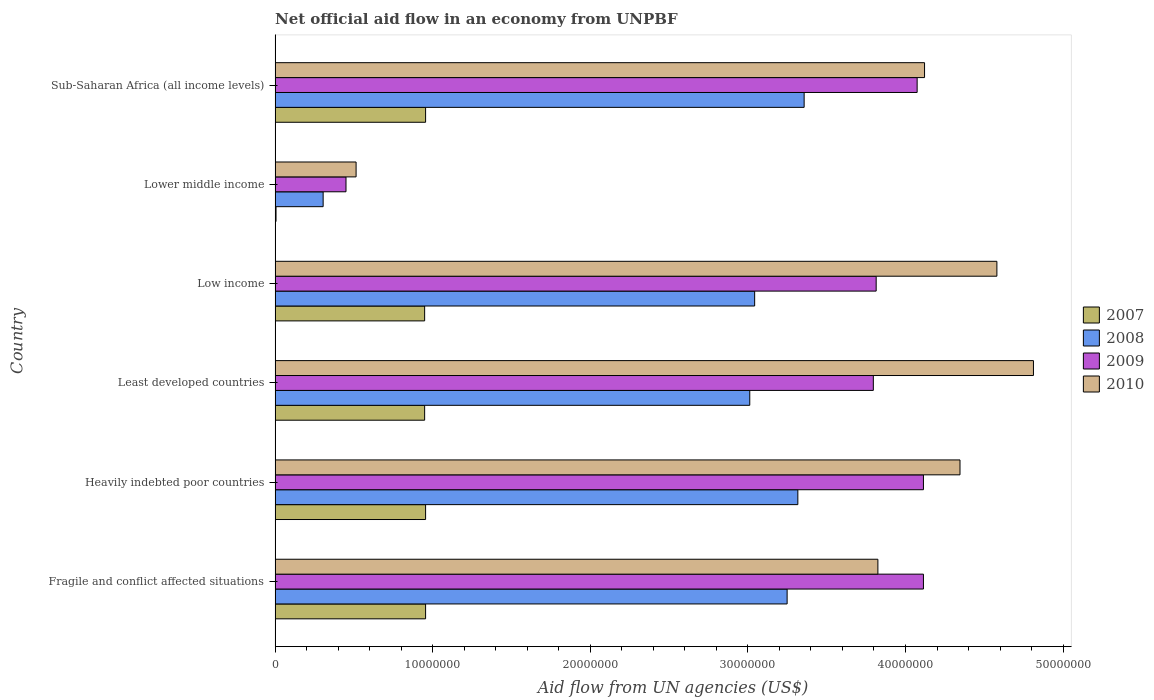How many different coloured bars are there?
Offer a terse response. 4. Are the number of bars on each tick of the Y-axis equal?
Provide a succinct answer. Yes. What is the label of the 2nd group of bars from the top?
Your answer should be compact. Lower middle income. In how many cases, is the number of bars for a given country not equal to the number of legend labels?
Provide a succinct answer. 0. What is the net official aid flow in 2010 in Sub-Saharan Africa (all income levels)?
Make the answer very short. 4.12e+07. Across all countries, what is the maximum net official aid flow in 2008?
Offer a terse response. 3.36e+07. Across all countries, what is the minimum net official aid flow in 2010?
Give a very brief answer. 5.14e+06. In which country was the net official aid flow in 2008 maximum?
Give a very brief answer. Sub-Saharan Africa (all income levels). In which country was the net official aid flow in 2008 minimum?
Give a very brief answer. Lower middle income. What is the total net official aid flow in 2008 in the graph?
Your answer should be very brief. 1.63e+08. What is the difference between the net official aid flow in 2007 in Low income and that in Sub-Saharan Africa (all income levels)?
Offer a terse response. -6.00e+04. What is the difference between the net official aid flow in 2009 in Sub-Saharan Africa (all income levels) and the net official aid flow in 2010 in Lower middle income?
Your answer should be very brief. 3.56e+07. What is the average net official aid flow in 2008 per country?
Provide a short and direct response. 2.71e+07. What is the difference between the net official aid flow in 2009 and net official aid flow in 2010 in Heavily indebted poor countries?
Keep it short and to the point. -2.32e+06. In how many countries, is the net official aid flow in 2010 greater than 48000000 US$?
Provide a short and direct response. 1. What is the ratio of the net official aid flow in 2010 in Lower middle income to that in Sub-Saharan Africa (all income levels)?
Your answer should be compact. 0.12. Is the net official aid flow in 2010 in Heavily indebted poor countries less than that in Least developed countries?
Provide a short and direct response. Yes. Is the difference between the net official aid flow in 2009 in Heavily indebted poor countries and Low income greater than the difference between the net official aid flow in 2010 in Heavily indebted poor countries and Low income?
Keep it short and to the point. Yes. What is the difference between the highest and the second highest net official aid flow in 2010?
Keep it short and to the point. 2.32e+06. What is the difference between the highest and the lowest net official aid flow in 2009?
Provide a succinct answer. 3.66e+07. In how many countries, is the net official aid flow in 2009 greater than the average net official aid flow in 2009 taken over all countries?
Your answer should be very brief. 5. What does the 2nd bar from the top in Fragile and conflict affected situations represents?
Give a very brief answer. 2009. How many bars are there?
Your answer should be very brief. 24. How many countries are there in the graph?
Your response must be concise. 6. Are the values on the major ticks of X-axis written in scientific E-notation?
Your answer should be compact. No. Does the graph contain any zero values?
Ensure brevity in your answer.  No. How many legend labels are there?
Your response must be concise. 4. What is the title of the graph?
Offer a terse response. Net official aid flow in an economy from UNPBF. Does "1980" appear as one of the legend labels in the graph?
Give a very brief answer. No. What is the label or title of the X-axis?
Your answer should be very brief. Aid flow from UN agencies (US$). What is the label or title of the Y-axis?
Give a very brief answer. Country. What is the Aid flow from UN agencies (US$) of 2007 in Fragile and conflict affected situations?
Give a very brief answer. 9.55e+06. What is the Aid flow from UN agencies (US$) in 2008 in Fragile and conflict affected situations?
Provide a succinct answer. 3.25e+07. What is the Aid flow from UN agencies (US$) of 2009 in Fragile and conflict affected situations?
Ensure brevity in your answer.  4.11e+07. What is the Aid flow from UN agencies (US$) of 2010 in Fragile and conflict affected situations?
Your answer should be compact. 3.82e+07. What is the Aid flow from UN agencies (US$) of 2007 in Heavily indebted poor countries?
Make the answer very short. 9.55e+06. What is the Aid flow from UN agencies (US$) in 2008 in Heavily indebted poor countries?
Your answer should be compact. 3.32e+07. What is the Aid flow from UN agencies (US$) of 2009 in Heavily indebted poor countries?
Your answer should be very brief. 4.11e+07. What is the Aid flow from UN agencies (US$) of 2010 in Heavily indebted poor countries?
Give a very brief answer. 4.35e+07. What is the Aid flow from UN agencies (US$) of 2007 in Least developed countries?
Your answer should be very brief. 9.49e+06. What is the Aid flow from UN agencies (US$) in 2008 in Least developed countries?
Your response must be concise. 3.01e+07. What is the Aid flow from UN agencies (US$) in 2009 in Least developed countries?
Keep it short and to the point. 3.80e+07. What is the Aid flow from UN agencies (US$) of 2010 in Least developed countries?
Offer a very short reply. 4.81e+07. What is the Aid flow from UN agencies (US$) in 2007 in Low income?
Make the answer very short. 9.49e+06. What is the Aid flow from UN agencies (US$) of 2008 in Low income?
Your response must be concise. 3.04e+07. What is the Aid flow from UN agencies (US$) in 2009 in Low income?
Your answer should be compact. 3.81e+07. What is the Aid flow from UN agencies (US$) in 2010 in Low income?
Provide a succinct answer. 4.58e+07. What is the Aid flow from UN agencies (US$) in 2007 in Lower middle income?
Provide a succinct answer. 6.00e+04. What is the Aid flow from UN agencies (US$) in 2008 in Lower middle income?
Keep it short and to the point. 3.05e+06. What is the Aid flow from UN agencies (US$) of 2009 in Lower middle income?
Provide a succinct answer. 4.50e+06. What is the Aid flow from UN agencies (US$) in 2010 in Lower middle income?
Give a very brief answer. 5.14e+06. What is the Aid flow from UN agencies (US$) in 2007 in Sub-Saharan Africa (all income levels)?
Provide a short and direct response. 9.55e+06. What is the Aid flow from UN agencies (US$) of 2008 in Sub-Saharan Africa (all income levels)?
Provide a succinct answer. 3.36e+07. What is the Aid flow from UN agencies (US$) in 2009 in Sub-Saharan Africa (all income levels)?
Offer a terse response. 4.07e+07. What is the Aid flow from UN agencies (US$) in 2010 in Sub-Saharan Africa (all income levels)?
Give a very brief answer. 4.12e+07. Across all countries, what is the maximum Aid flow from UN agencies (US$) in 2007?
Keep it short and to the point. 9.55e+06. Across all countries, what is the maximum Aid flow from UN agencies (US$) in 2008?
Provide a short and direct response. 3.36e+07. Across all countries, what is the maximum Aid flow from UN agencies (US$) of 2009?
Your answer should be compact. 4.11e+07. Across all countries, what is the maximum Aid flow from UN agencies (US$) in 2010?
Provide a short and direct response. 4.81e+07. Across all countries, what is the minimum Aid flow from UN agencies (US$) of 2007?
Make the answer very short. 6.00e+04. Across all countries, what is the minimum Aid flow from UN agencies (US$) of 2008?
Offer a terse response. 3.05e+06. Across all countries, what is the minimum Aid flow from UN agencies (US$) of 2009?
Offer a very short reply. 4.50e+06. Across all countries, what is the minimum Aid flow from UN agencies (US$) in 2010?
Ensure brevity in your answer.  5.14e+06. What is the total Aid flow from UN agencies (US$) in 2007 in the graph?
Your answer should be compact. 4.77e+07. What is the total Aid flow from UN agencies (US$) of 2008 in the graph?
Offer a terse response. 1.63e+08. What is the total Aid flow from UN agencies (US$) in 2009 in the graph?
Provide a succinct answer. 2.04e+08. What is the total Aid flow from UN agencies (US$) in 2010 in the graph?
Give a very brief answer. 2.22e+08. What is the difference between the Aid flow from UN agencies (US$) in 2007 in Fragile and conflict affected situations and that in Heavily indebted poor countries?
Offer a terse response. 0. What is the difference between the Aid flow from UN agencies (US$) in 2008 in Fragile and conflict affected situations and that in Heavily indebted poor countries?
Your answer should be very brief. -6.80e+05. What is the difference between the Aid flow from UN agencies (US$) in 2010 in Fragile and conflict affected situations and that in Heavily indebted poor countries?
Your response must be concise. -5.21e+06. What is the difference between the Aid flow from UN agencies (US$) in 2008 in Fragile and conflict affected situations and that in Least developed countries?
Provide a short and direct response. 2.37e+06. What is the difference between the Aid flow from UN agencies (US$) in 2009 in Fragile and conflict affected situations and that in Least developed countries?
Make the answer very short. 3.18e+06. What is the difference between the Aid flow from UN agencies (US$) in 2010 in Fragile and conflict affected situations and that in Least developed countries?
Keep it short and to the point. -9.87e+06. What is the difference between the Aid flow from UN agencies (US$) in 2008 in Fragile and conflict affected situations and that in Low income?
Give a very brief answer. 2.06e+06. What is the difference between the Aid flow from UN agencies (US$) in 2010 in Fragile and conflict affected situations and that in Low income?
Your response must be concise. -7.55e+06. What is the difference between the Aid flow from UN agencies (US$) of 2007 in Fragile and conflict affected situations and that in Lower middle income?
Your answer should be very brief. 9.49e+06. What is the difference between the Aid flow from UN agencies (US$) in 2008 in Fragile and conflict affected situations and that in Lower middle income?
Keep it short and to the point. 2.94e+07. What is the difference between the Aid flow from UN agencies (US$) in 2009 in Fragile and conflict affected situations and that in Lower middle income?
Your answer should be very brief. 3.66e+07. What is the difference between the Aid flow from UN agencies (US$) in 2010 in Fragile and conflict affected situations and that in Lower middle income?
Your answer should be very brief. 3.31e+07. What is the difference between the Aid flow from UN agencies (US$) in 2007 in Fragile and conflict affected situations and that in Sub-Saharan Africa (all income levels)?
Ensure brevity in your answer.  0. What is the difference between the Aid flow from UN agencies (US$) in 2008 in Fragile and conflict affected situations and that in Sub-Saharan Africa (all income levels)?
Give a very brief answer. -1.08e+06. What is the difference between the Aid flow from UN agencies (US$) of 2010 in Fragile and conflict affected situations and that in Sub-Saharan Africa (all income levels)?
Ensure brevity in your answer.  -2.96e+06. What is the difference between the Aid flow from UN agencies (US$) of 2007 in Heavily indebted poor countries and that in Least developed countries?
Give a very brief answer. 6.00e+04. What is the difference between the Aid flow from UN agencies (US$) in 2008 in Heavily indebted poor countries and that in Least developed countries?
Offer a terse response. 3.05e+06. What is the difference between the Aid flow from UN agencies (US$) of 2009 in Heavily indebted poor countries and that in Least developed countries?
Ensure brevity in your answer.  3.18e+06. What is the difference between the Aid flow from UN agencies (US$) of 2010 in Heavily indebted poor countries and that in Least developed countries?
Offer a terse response. -4.66e+06. What is the difference between the Aid flow from UN agencies (US$) in 2007 in Heavily indebted poor countries and that in Low income?
Provide a succinct answer. 6.00e+04. What is the difference between the Aid flow from UN agencies (US$) of 2008 in Heavily indebted poor countries and that in Low income?
Offer a terse response. 2.74e+06. What is the difference between the Aid flow from UN agencies (US$) in 2009 in Heavily indebted poor countries and that in Low income?
Your response must be concise. 3.00e+06. What is the difference between the Aid flow from UN agencies (US$) of 2010 in Heavily indebted poor countries and that in Low income?
Keep it short and to the point. -2.34e+06. What is the difference between the Aid flow from UN agencies (US$) of 2007 in Heavily indebted poor countries and that in Lower middle income?
Provide a succinct answer. 9.49e+06. What is the difference between the Aid flow from UN agencies (US$) in 2008 in Heavily indebted poor countries and that in Lower middle income?
Provide a short and direct response. 3.01e+07. What is the difference between the Aid flow from UN agencies (US$) of 2009 in Heavily indebted poor countries and that in Lower middle income?
Your response must be concise. 3.66e+07. What is the difference between the Aid flow from UN agencies (US$) of 2010 in Heavily indebted poor countries and that in Lower middle income?
Keep it short and to the point. 3.83e+07. What is the difference between the Aid flow from UN agencies (US$) of 2007 in Heavily indebted poor countries and that in Sub-Saharan Africa (all income levels)?
Make the answer very short. 0. What is the difference between the Aid flow from UN agencies (US$) of 2008 in Heavily indebted poor countries and that in Sub-Saharan Africa (all income levels)?
Keep it short and to the point. -4.00e+05. What is the difference between the Aid flow from UN agencies (US$) of 2009 in Heavily indebted poor countries and that in Sub-Saharan Africa (all income levels)?
Your answer should be very brief. 4.00e+05. What is the difference between the Aid flow from UN agencies (US$) of 2010 in Heavily indebted poor countries and that in Sub-Saharan Africa (all income levels)?
Provide a succinct answer. 2.25e+06. What is the difference between the Aid flow from UN agencies (US$) in 2008 in Least developed countries and that in Low income?
Your answer should be very brief. -3.10e+05. What is the difference between the Aid flow from UN agencies (US$) of 2009 in Least developed countries and that in Low income?
Provide a short and direct response. -1.80e+05. What is the difference between the Aid flow from UN agencies (US$) of 2010 in Least developed countries and that in Low income?
Your answer should be very brief. 2.32e+06. What is the difference between the Aid flow from UN agencies (US$) in 2007 in Least developed countries and that in Lower middle income?
Ensure brevity in your answer.  9.43e+06. What is the difference between the Aid flow from UN agencies (US$) in 2008 in Least developed countries and that in Lower middle income?
Your answer should be very brief. 2.71e+07. What is the difference between the Aid flow from UN agencies (US$) in 2009 in Least developed countries and that in Lower middle income?
Make the answer very short. 3.35e+07. What is the difference between the Aid flow from UN agencies (US$) of 2010 in Least developed countries and that in Lower middle income?
Your answer should be compact. 4.30e+07. What is the difference between the Aid flow from UN agencies (US$) in 2008 in Least developed countries and that in Sub-Saharan Africa (all income levels)?
Your answer should be very brief. -3.45e+06. What is the difference between the Aid flow from UN agencies (US$) in 2009 in Least developed countries and that in Sub-Saharan Africa (all income levels)?
Give a very brief answer. -2.78e+06. What is the difference between the Aid flow from UN agencies (US$) in 2010 in Least developed countries and that in Sub-Saharan Africa (all income levels)?
Ensure brevity in your answer.  6.91e+06. What is the difference between the Aid flow from UN agencies (US$) in 2007 in Low income and that in Lower middle income?
Your answer should be very brief. 9.43e+06. What is the difference between the Aid flow from UN agencies (US$) of 2008 in Low income and that in Lower middle income?
Ensure brevity in your answer.  2.74e+07. What is the difference between the Aid flow from UN agencies (US$) of 2009 in Low income and that in Lower middle income?
Keep it short and to the point. 3.36e+07. What is the difference between the Aid flow from UN agencies (US$) of 2010 in Low income and that in Lower middle income?
Make the answer very short. 4.07e+07. What is the difference between the Aid flow from UN agencies (US$) in 2008 in Low income and that in Sub-Saharan Africa (all income levels)?
Offer a very short reply. -3.14e+06. What is the difference between the Aid flow from UN agencies (US$) in 2009 in Low income and that in Sub-Saharan Africa (all income levels)?
Offer a terse response. -2.60e+06. What is the difference between the Aid flow from UN agencies (US$) of 2010 in Low income and that in Sub-Saharan Africa (all income levels)?
Ensure brevity in your answer.  4.59e+06. What is the difference between the Aid flow from UN agencies (US$) in 2007 in Lower middle income and that in Sub-Saharan Africa (all income levels)?
Keep it short and to the point. -9.49e+06. What is the difference between the Aid flow from UN agencies (US$) in 2008 in Lower middle income and that in Sub-Saharan Africa (all income levels)?
Offer a very short reply. -3.05e+07. What is the difference between the Aid flow from UN agencies (US$) of 2009 in Lower middle income and that in Sub-Saharan Africa (all income levels)?
Make the answer very short. -3.62e+07. What is the difference between the Aid flow from UN agencies (US$) in 2010 in Lower middle income and that in Sub-Saharan Africa (all income levels)?
Offer a terse response. -3.61e+07. What is the difference between the Aid flow from UN agencies (US$) in 2007 in Fragile and conflict affected situations and the Aid flow from UN agencies (US$) in 2008 in Heavily indebted poor countries?
Provide a succinct answer. -2.36e+07. What is the difference between the Aid flow from UN agencies (US$) in 2007 in Fragile and conflict affected situations and the Aid flow from UN agencies (US$) in 2009 in Heavily indebted poor countries?
Offer a terse response. -3.16e+07. What is the difference between the Aid flow from UN agencies (US$) of 2007 in Fragile and conflict affected situations and the Aid flow from UN agencies (US$) of 2010 in Heavily indebted poor countries?
Your answer should be very brief. -3.39e+07. What is the difference between the Aid flow from UN agencies (US$) of 2008 in Fragile and conflict affected situations and the Aid flow from UN agencies (US$) of 2009 in Heavily indebted poor countries?
Offer a very short reply. -8.65e+06. What is the difference between the Aid flow from UN agencies (US$) of 2008 in Fragile and conflict affected situations and the Aid flow from UN agencies (US$) of 2010 in Heavily indebted poor countries?
Provide a short and direct response. -1.10e+07. What is the difference between the Aid flow from UN agencies (US$) of 2009 in Fragile and conflict affected situations and the Aid flow from UN agencies (US$) of 2010 in Heavily indebted poor countries?
Offer a very short reply. -2.32e+06. What is the difference between the Aid flow from UN agencies (US$) of 2007 in Fragile and conflict affected situations and the Aid flow from UN agencies (US$) of 2008 in Least developed countries?
Provide a short and direct response. -2.06e+07. What is the difference between the Aid flow from UN agencies (US$) in 2007 in Fragile and conflict affected situations and the Aid flow from UN agencies (US$) in 2009 in Least developed countries?
Offer a terse response. -2.84e+07. What is the difference between the Aid flow from UN agencies (US$) of 2007 in Fragile and conflict affected situations and the Aid flow from UN agencies (US$) of 2010 in Least developed countries?
Your answer should be very brief. -3.86e+07. What is the difference between the Aid flow from UN agencies (US$) in 2008 in Fragile and conflict affected situations and the Aid flow from UN agencies (US$) in 2009 in Least developed countries?
Ensure brevity in your answer.  -5.47e+06. What is the difference between the Aid flow from UN agencies (US$) in 2008 in Fragile and conflict affected situations and the Aid flow from UN agencies (US$) in 2010 in Least developed countries?
Offer a terse response. -1.56e+07. What is the difference between the Aid flow from UN agencies (US$) in 2009 in Fragile and conflict affected situations and the Aid flow from UN agencies (US$) in 2010 in Least developed countries?
Your response must be concise. -6.98e+06. What is the difference between the Aid flow from UN agencies (US$) in 2007 in Fragile and conflict affected situations and the Aid flow from UN agencies (US$) in 2008 in Low income?
Give a very brief answer. -2.09e+07. What is the difference between the Aid flow from UN agencies (US$) in 2007 in Fragile and conflict affected situations and the Aid flow from UN agencies (US$) in 2009 in Low income?
Your response must be concise. -2.86e+07. What is the difference between the Aid flow from UN agencies (US$) of 2007 in Fragile and conflict affected situations and the Aid flow from UN agencies (US$) of 2010 in Low income?
Give a very brief answer. -3.62e+07. What is the difference between the Aid flow from UN agencies (US$) of 2008 in Fragile and conflict affected situations and the Aid flow from UN agencies (US$) of 2009 in Low income?
Offer a terse response. -5.65e+06. What is the difference between the Aid flow from UN agencies (US$) of 2008 in Fragile and conflict affected situations and the Aid flow from UN agencies (US$) of 2010 in Low income?
Make the answer very short. -1.33e+07. What is the difference between the Aid flow from UN agencies (US$) in 2009 in Fragile and conflict affected situations and the Aid flow from UN agencies (US$) in 2010 in Low income?
Your answer should be compact. -4.66e+06. What is the difference between the Aid flow from UN agencies (US$) of 2007 in Fragile and conflict affected situations and the Aid flow from UN agencies (US$) of 2008 in Lower middle income?
Provide a succinct answer. 6.50e+06. What is the difference between the Aid flow from UN agencies (US$) in 2007 in Fragile and conflict affected situations and the Aid flow from UN agencies (US$) in 2009 in Lower middle income?
Offer a very short reply. 5.05e+06. What is the difference between the Aid flow from UN agencies (US$) in 2007 in Fragile and conflict affected situations and the Aid flow from UN agencies (US$) in 2010 in Lower middle income?
Keep it short and to the point. 4.41e+06. What is the difference between the Aid flow from UN agencies (US$) in 2008 in Fragile and conflict affected situations and the Aid flow from UN agencies (US$) in 2009 in Lower middle income?
Your answer should be very brief. 2.80e+07. What is the difference between the Aid flow from UN agencies (US$) in 2008 in Fragile and conflict affected situations and the Aid flow from UN agencies (US$) in 2010 in Lower middle income?
Your response must be concise. 2.74e+07. What is the difference between the Aid flow from UN agencies (US$) of 2009 in Fragile and conflict affected situations and the Aid flow from UN agencies (US$) of 2010 in Lower middle income?
Ensure brevity in your answer.  3.60e+07. What is the difference between the Aid flow from UN agencies (US$) in 2007 in Fragile and conflict affected situations and the Aid flow from UN agencies (US$) in 2008 in Sub-Saharan Africa (all income levels)?
Offer a terse response. -2.40e+07. What is the difference between the Aid flow from UN agencies (US$) in 2007 in Fragile and conflict affected situations and the Aid flow from UN agencies (US$) in 2009 in Sub-Saharan Africa (all income levels)?
Your answer should be very brief. -3.12e+07. What is the difference between the Aid flow from UN agencies (US$) in 2007 in Fragile and conflict affected situations and the Aid flow from UN agencies (US$) in 2010 in Sub-Saharan Africa (all income levels)?
Make the answer very short. -3.17e+07. What is the difference between the Aid flow from UN agencies (US$) in 2008 in Fragile and conflict affected situations and the Aid flow from UN agencies (US$) in 2009 in Sub-Saharan Africa (all income levels)?
Your answer should be compact. -8.25e+06. What is the difference between the Aid flow from UN agencies (US$) in 2008 in Fragile and conflict affected situations and the Aid flow from UN agencies (US$) in 2010 in Sub-Saharan Africa (all income levels)?
Your response must be concise. -8.72e+06. What is the difference between the Aid flow from UN agencies (US$) in 2009 in Fragile and conflict affected situations and the Aid flow from UN agencies (US$) in 2010 in Sub-Saharan Africa (all income levels)?
Provide a succinct answer. -7.00e+04. What is the difference between the Aid flow from UN agencies (US$) in 2007 in Heavily indebted poor countries and the Aid flow from UN agencies (US$) in 2008 in Least developed countries?
Offer a very short reply. -2.06e+07. What is the difference between the Aid flow from UN agencies (US$) of 2007 in Heavily indebted poor countries and the Aid flow from UN agencies (US$) of 2009 in Least developed countries?
Provide a succinct answer. -2.84e+07. What is the difference between the Aid flow from UN agencies (US$) of 2007 in Heavily indebted poor countries and the Aid flow from UN agencies (US$) of 2010 in Least developed countries?
Your answer should be very brief. -3.86e+07. What is the difference between the Aid flow from UN agencies (US$) in 2008 in Heavily indebted poor countries and the Aid flow from UN agencies (US$) in 2009 in Least developed countries?
Give a very brief answer. -4.79e+06. What is the difference between the Aid flow from UN agencies (US$) in 2008 in Heavily indebted poor countries and the Aid flow from UN agencies (US$) in 2010 in Least developed countries?
Make the answer very short. -1.50e+07. What is the difference between the Aid flow from UN agencies (US$) in 2009 in Heavily indebted poor countries and the Aid flow from UN agencies (US$) in 2010 in Least developed countries?
Offer a terse response. -6.98e+06. What is the difference between the Aid flow from UN agencies (US$) of 2007 in Heavily indebted poor countries and the Aid flow from UN agencies (US$) of 2008 in Low income?
Provide a succinct answer. -2.09e+07. What is the difference between the Aid flow from UN agencies (US$) in 2007 in Heavily indebted poor countries and the Aid flow from UN agencies (US$) in 2009 in Low income?
Keep it short and to the point. -2.86e+07. What is the difference between the Aid flow from UN agencies (US$) of 2007 in Heavily indebted poor countries and the Aid flow from UN agencies (US$) of 2010 in Low income?
Offer a terse response. -3.62e+07. What is the difference between the Aid flow from UN agencies (US$) in 2008 in Heavily indebted poor countries and the Aid flow from UN agencies (US$) in 2009 in Low income?
Provide a short and direct response. -4.97e+06. What is the difference between the Aid flow from UN agencies (US$) of 2008 in Heavily indebted poor countries and the Aid flow from UN agencies (US$) of 2010 in Low income?
Your answer should be compact. -1.26e+07. What is the difference between the Aid flow from UN agencies (US$) in 2009 in Heavily indebted poor countries and the Aid flow from UN agencies (US$) in 2010 in Low income?
Make the answer very short. -4.66e+06. What is the difference between the Aid flow from UN agencies (US$) of 2007 in Heavily indebted poor countries and the Aid flow from UN agencies (US$) of 2008 in Lower middle income?
Your response must be concise. 6.50e+06. What is the difference between the Aid flow from UN agencies (US$) in 2007 in Heavily indebted poor countries and the Aid flow from UN agencies (US$) in 2009 in Lower middle income?
Make the answer very short. 5.05e+06. What is the difference between the Aid flow from UN agencies (US$) in 2007 in Heavily indebted poor countries and the Aid flow from UN agencies (US$) in 2010 in Lower middle income?
Your response must be concise. 4.41e+06. What is the difference between the Aid flow from UN agencies (US$) of 2008 in Heavily indebted poor countries and the Aid flow from UN agencies (US$) of 2009 in Lower middle income?
Your response must be concise. 2.87e+07. What is the difference between the Aid flow from UN agencies (US$) in 2008 in Heavily indebted poor countries and the Aid flow from UN agencies (US$) in 2010 in Lower middle income?
Your answer should be very brief. 2.80e+07. What is the difference between the Aid flow from UN agencies (US$) in 2009 in Heavily indebted poor countries and the Aid flow from UN agencies (US$) in 2010 in Lower middle income?
Keep it short and to the point. 3.60e+07. What is the difference between the Aid flow from UN agencies (US$) of 2007 in Heavily indebted poor countries and the Aid flow from UN agencies (US$) of 2008 in Sub-Saharan Africa (all income levels)?
Your response must be concise. -2.40e+07. What is the difference between the Aid flow from UN agencies (US$) in 2007 in Heavily indebted poor countries and the Aid flow from UN agencies (US$) in 2009 in Sub-Saharan Africa (all income levels)?
Offer a very short reply. -3.12e+07. What is the difference between the Aid flow from UN agencies (US$) in 2007 in Heavily indebted poor countries and the Aid flow from UN agencies (US$) in 2010 in Sub-Saharan Africa (all income levels)?
Ensure brevity in your answer.  -3.17e+07. What is the difference between the Aid flow from UN agencies (US$) of 2008 in Heavily indebted poor countries and the Aid flow from UN agencies (US$) of 2009 in Sub-Saharan Africa (all income levels)?
Provide a short and direct response. -7.57e+06. What is the difference between the Aid flow from UN agencies (US$) of 2008 in Heavily indebted poor countries and the Aid flow from UN agencies (US$) of 2010 in Sub-Saharan Africa (all income levels)?
Provide a short and direct response. -8.04e+06. What is the difference between the Aid flow from UN agencies (US$) in 2009 in Heavily indebted poor countries and the Aid flow from UN agencies (US$) in 2010 in Sub-Saharan Africa (all income levels)?
Keep it short and to the point. -7.00e+04. What is the difference between the Aid flow from UN agencies (US$) of 2007 in Least developed countries and the Aid flow from UN agencies (US$) of 2008 in Low income?
Make the answer very short. -2.09e+07. What is the difference between the Aid flow from UN agencies (US$) of 2007 in Least developed countries and the Aid flow from UN agencies (US$) of 2009 in Low income?
Provide a succinct answer. -2.86e+07. What is the difference between the Aid flow from UN agencies (US$) of 2007 in Least developed countries and the Aid flow from UN agencies (US$) of 2010 in Low income?
Ensure brevity in your answer.  -3.63e+07. What is the difference between the Aid flow from UN agencies (US$) of 2008 in Least developed countries and the Aid flow from UN agencies (US$) of 2009 in Low income?
Ensure brevity in your answer.  -8.02e+06. What is the difference between the Aid flow from UN agencies (US$) in 2008 in Least developed countries and the Aid flow from UN agencies (US$) in 2010 in Low income?
Your response must be concise. -1.57e+07. What is the difference between the Aid flow from UN agencies (US$) of 2009 in Least developed countries and the Aid flow from UN agencies (US$) of 2010 in Low income?
Ensure brevity in your answer.  -7.84e+06. What is the difference between the Aid flow from UN agencies (US$) in 2007 in Least developed countries and the Aid flow from UN agencies (US$) in 2008 in Lower middle income?
Your answer should be compact. 6.44e+06. What is the difference between the Aid flow from UN agencies (US$) of 2007 in Least developed countries and the Aid flow from UN agencies (US$) of 2009 in Lower middle income?
Your answer should be compact. 4.99e+06. What is the difference between the Aid flow from UN agencies (US$) of 2007 in Least developed countries and the Aid flow from UN agencies (US$) of 2010 in Lower middle income?
Your answer should be very brief. 4.35e+06. What is the difference between the Aid flow from UN agencies (US$) of 2008 in Least developed countries and the Aid flow from UN agencies (US$) of 2009 in Lower middle income?
Give a very brief answer. 2.56e+07. What is the difference between the Aid flow from UN agencies (US$) in 2008 in Least developed countries and the Aid flow from UN agencies (US$) in 2010 in Lower middle income?
Offer a terse response. 2.50e+07. What is the difference between the Aid flow from UN agencies (US$) of 2009 in Least developed countries and the Aid flow from UN agencies (US$) of 2010 in Lower middle income?
Make the answer very short. 3.28e+07. What is the difference between the Aid flow from UN agencies (US$) in 2007 in Least developed countries and the Aid flow from UN agencies (US$) in 2008 in Sub-Saharan Africa (all income levels)?
Offer a terse response. -2.41e+07. What is the difference between the Aid flow from UN agencies (US$) of 2007 in Least developed countries and the Aid flow from UN agencies (US$) of 2009 in Sub-Saharan Africa (all income levels)?
Keep it short and to the point. -3.12e+07. What is the difference between the Aid flow from UN agencies (US$) in 2007 in Least developed countries and the Aid flow from UN agencies (US$) in 2010 in Sub-Saharan Africa (all income levels)?
Provide a short and direct response. -3.17e+07. What is the difference between the Aid flow from UN agencies (US$) of 2008 in Least developed countries and the Aid flow from UN agencies (US$) of 2009 in Sub-Saharan Africa (all income levels)?
Your answer should be compact. -1.06e+07. What is the difference between the Aid flow from UN agencies (US$) of 2008 in Least developed countries and the Aid flow from UN agencies (US$) of 2010 in Sub-Saharan Africa (all income levels)?
Provide a succinct answer. -1.11e+07. What is the difference between the Aid flow from UN agencies (US$) in 2009 in Least developed countries and the Aid flow from UN agencies (US$) in 2010 in Sub-Saharan Africa (all income levels)?
Offer a very short reply. -3.25e+06. What is the difference between the Aid flow from UN agencies (US$) in 2007 in Low income and the Aid flow from UN agencies (US$) in 2008 in Lower middle income?
Keep it short and to the point. 6.44e+06. What is the difference between the Aid flow from UN agencies (US$) in 2007 in Low income and the Aid flow from UN agencies (US$) in 2009 in Lower middle income?
Provide a succinct answer. 4.99e+06. What is the difference between the Aid flow from UN agencies (US$) of 2007 in Low income and the Aid flow from UN agencies (US$) of 2010 in Lower middle income?
Your response must be concise. 4.35e+06. What is the difference between the Aid flow from UN agencies (US$) of 2008 in Low income and the Aid flow from UN agencies (US$) of 2009 in Lower middle income?
Provide a short and direct response. 2.59e+07. What is the difference between the Aid flow from UN agencies (US$) in 2008 in Low income and the Aid flow from UN agencies (US$) in 2010 in Lower middle income?
Give a very brief answer. 2.53e+07. What is the difference between the Aid flow from UN agencies (US$) in 2009 in Low income and the Aid flow from UN agencies (US$) in 2010 in Lower middle income?
Make the answer very short. 3.30e+07. What is the difference between the Aid flow from UN agencies (US$) of 2007 in Low income and the Aid flow from UN agencies (US$) of 2008 in Sub-Saharan Africa (all income levels)?
Offer a terse response. -2.41e+07. What is the difference between the Aid flow from UN agencies (US$) in 2007 in Low income and the Aid flow from UN agencies (US$) in 2009 in Sub-Saharan Africa (all income levels)?
Give a very brief answer. -3.12e+07. What is the difference between the Aid flow from UN agencies (US$) in 2007 in Low income and the Aid flow from UN agencies (US$) in 2010 in Sub-Saharan Africa (all income levels)?
Your answer should be very brief. -3.17e+07. What is the difference between the Aid flow from UN agencies (US$) in 2008 in Low income and the Aid flow from UN agencies (US$) in 2009 in Sub-Saharan Africa (all income levels)?
Your response must be concise. -1.03e+07. What is the difference between the Aid flow from UN agencies (US$) in 2008 in Low income and the Aid flow from UN agencies (US$) in 2010 in Sub-Saharan Africa (all income levels)?
Offer a terse response. -1.08e+07. What is the difference between the Aid flow from UN agencies (US$) in 2009 in Low income and the Aid flow from UN agencies (US$) in 2010 in Sub-Saharan Africa (all income levels)?
Make the answer very short. -3.07e+06. What is the difference between the Aid flow from UN agencies (US$) of 2007 in Lower middle income and the Aid flow from UN agencies (US$) of 2008 in Sub-Saharan Africa (all income levels)?
Make the answer very short. -3.35e+07. What is the difference between the Aid flow from UN agencies (US$) in 2007 in Lower middle income and the Aid flow from UN agencies (US$) in 2009 in Sub-Saharan Africa (all income levels)?
Make the answer very short. -4.07e+07. What is the difference between the Aid flow from UN agencies (US$) of 2007 in Lower middle income and the Aid flow from UN agencies (US$) of 2010 in Sub-Saharan Africa (all income levels)?
Provide a succinct answer. -4.12e+07. What is the difference between the Aid flow from UN agencies (US$) in 2008 in Lower middle income and the Aid flow from UN agencies (US$) in 2009 in Sub-Saharan Africa (all income levels)?
Ensure brevity in your answer.  -3.77e+07. What is the difference between the Aid flow from UN agencies (US$) in 2008 in Lower middle income and the Aid flow from UN agencies (US$) in 2010 in Sub-Saharan Africa (all income levels)?
Your answer should be very brief. -3.82e+07. What is the difference between the Aid flow from UN agencies (US$) in 2009 in Lower middle income and the Aid flow from UN agencies (US$) in 2010 in Sub-Saharan Africa (all income levels)?
Provide a succinct answer. -3.67e+07. What is the average Aid flow from UN agencies (US$) of 2007 per country?
Provide a succinct answer. 7.95e+06. What is the average Aid flow from UN agencies (US$) in 2008 per country?
Keep it short and to the point. 2.71e+07. What is the average Aid flow from UN agencies (US$) in 2009 per country?
Keep it short and to the point. 3.39e+07. What is the average Aid flow from UN agencies (US$) in 2010 per country?
Provide a succinct answer. 3.70e+07. What is the difference between the Aid flow from UN agencies (US$) in 2007 and Aid flow from UN agencies (US$) in 2008 in Fragile and conflict affected situations?
Your response must be concise. -2.29e+07. What is the difference between the Aid flow from UN agencies (US$) of 2007 and Aid flow from UN agencies (US$) of 2009 in Fragile and conflict affected situations?
Provide a succinct answer. -3.16e+07. What is the difference between the Aid flow from UN agencies (US$) in 2007 and Aid flow from UN agencies (US$) in 2010 in Fragile and conflict affected situations?
Provide a short and direct response. -2.87e+07. What is the difference between the Aid flow from UN agencies (US$) of 2008 and Aid flow from UN agencies (US$) of 2009 in Fragile and conflict affected situations?
Provide a succinct answer. -8.65e+06. What is the difference between the Aid flow from UN agencies (US$) in 2008 and Aid flow from UN agencies (US$) in 2010 in Fragile and conflict affected situations?
Give a very brief answer. -5.76e+06. What is the difference between the Aid flow from UN agencies (US$) of 2009 and Aid flow from UN agencies (US$) of 2010 in Fragile and conflict affected situations?
Your answer should be compact. 2.89e+06. What is the difference between the Aid flow from UN agencies (US$) in 2007 and Aid flow from UN agencies (US$) in 2008 in Heavily indebted poor countries?
Make the answer very short. -2.36e+07. What is the difference between the Aid flow from UN agencies (US$) of 2007 and Aid flow from UN agencies (US$) of 2009 in Heavily indebted poor countries?
Ensure brevity in your answer.  -3.16e+07. What is the difference between the Aid flow from UN agencies (US$) in 2007 and Aid flow from UN agencies (US$) in 2010 in Heavily indebted poor countries?
Give a very brief answer. -3.39e+07. What is the difference between the Aid flow from UN agencies (US$) in 2008 and Aid flow from UN agencies (US$) in 2009 in Heavily indebted poor countries?
Your answer should be compact. -7.97e+06. What is the difference between the Aid flow from UN agencies (US$) in 2008 and Aid flow from UN agencies (US$) in 2010 in Heavily indebted poor countries?
Your answer should be compact. -1.03e+07. What is the difference between the Aid flow from UN agencies (US$) in 2009 and Aid flow from UN agencies (US$) in 2010 in Heavily indebted poor countries?
Your response must be concise. -2.32e+06. What is the difference between the Aid flow from UN agencies (US$) of 2007 and Aid flow from UN agencies (US$) of 2008 in Least developed countries?
Ensure brevity in your answer.  -2.06e+07. What is the difference between the Aid flow from UN agencies (US$) of 2007 and Aid flow from UN agencies (US$) of 2009 in Least developed countries?
Provide a short and direct response. -2.85e+07. What is the difference between the Aid flow from UN agencies (US$) of 2007 and Aid flow from UN agencies (US$) of 2010 in Least developed countries?
Offer a terse response. -3.86e+07. What is the difference between the Aid flow from UN agencies (US$) in 2008 and Aid flow from UN agencies (US$) in 2009 in Least developed countries?
Your response must be concise. -7.84e+06. What is the difference between the Aid flow from UN agencies (US$) in 2008 and Aid flow from UN agencies (US$) in 2010 in Least developed countries?
Keep it short and to the point. -1.80e+07. What is the difference between the Aid flow from UN agencies (US$) of 2009 and Aid flow from UN agencies (US$) of 2010 in Least developed countries?
Offer a very short reply. -1.02e+07. What is the difference between the Aid flow from UN agencies (US$) in 2007 and Aid flow from UN agencies (US$) in 2008 in Low income?
Provide a succinct answer. -2.09e+07. What is the difference between the Aid flow from UN agencies (US$) of 2007 and Aid flow from UN agencies (US$) of 2009 in Low income?
Offer a very short reply. -2.86e+07. What is the difference between the Aid flow from UN agencies (US$) of 2007 and Aid flow from UN agencies (US$) of 2010 in Low income?
Make the answer very short. -3.63e+07. What is the difference between the Aid flow from UN agencies (US$) in 2008 and Aid flow from UN agencies (US$) in 2009 in Low income?
Give a very brief answer. -7.71e+06. What is the difference between the Aid flow from UN agencies (US$) of 2008 and Aid flow from UN agencies (US$) of 2010 in Low income?
Your answer should be compact. -1.54e+07. What is the difference between the Aid flow from UN agencies (US$) in 2009 and Aid flow from UN agencies (US$) in 2010 in Low income?
Keep it short and to the point. -7.66e+06. What is the difference between the Aid flow from UN agencies (US$) of 2007 and Aid flow from UN agencies (US$) of 2008 in Lower middle income?
Provide a short and direct response. -2.99e+06. What is the difference between the Aid flow from UN agencies (US$) of 2007 and Aid flow from UN agencies (US$) of 2009 in Lower middle income?
Ensure brevity in your answer.  -4.44e+06. What is the difference between the Aid flow from UN agencies (US$) of 2007 and Aid flow from UN agencies (US$) of 2010 in Lower middle income?
Make the answer very short. -5.08e+06. What is the difference between the Aid flow from UN agencies (US$) in 2008 and Aid flow from UN agencies (US$) in 2009 in Lower middle income?
Provide a succinct answer. -1.45e+06. What is the difference between the Aid flow from UN agencies (US$) of 2008 and Aid flow from UN agencies (US$) of 2010 in Lower middle income?
Your response must be concise. -2.09e+06. What is the difference between the Aid flow from UN agencies (US$) in 2009 and Aid flow from UN agencies (US$) in 2010 in Lower middle income?
Offer a terse response. -6.40e+05. What is the difference between the Aid flow from UN agencies (US$) in 2007 and Aid flow from UN agencies (US$) in 2008 in Sub-Saharan Africa (all income levels)?
Offer a very short reply. -2.40e+07. What is the difference between the Aid flow from UN agencies (US$) of 2007 and Aid flow from UN agencies (US$) of 2009 in Sub-Saharan Africa (all income levels)?
Your response must be concise. -3.12e+07. What is the difference between the Aid flow from UN agencies (US$) in 2007 and Aid flow from UN agencies (US$) in 2010 in Sub-Saharan Africa (all income levels)?
Make the answer very short. -3.17e+07. What is the difference between the Aid flow from UN agencies (US$) in 2008 and Aid flow from UN agencies (US$) in 2009 in Sub-Saharan Africa (all income levels)?
Your answer should be very brief. -7.17e+06. What is the difference between the Aid flow from UN agencies (US$) in 2008 and Aid flow from UN agencies (US$) in 2010 in Sub-Saharan Africa (all income levels)?
Offer a terse response. -7.64e+06. What is the difference between the Aid flow from UN agencies (US$) in 2009 and Aid flow from UN agencies (US$) in 2010 in Sub-Saharan Africa (all income levels)?
Your response must be concise. -4.70e+05. What is the ratio of the Aid flow from UN agencies (US$) in 2007 in Fragile and conflict affected situations to that in Heavily indebted poor countries?
Your response must be concise. 1. What is the ratio of the Aid flow from UN agencies (US$) of 2008 in Fragile and conflict affected situations to that in Heavily indebted poor countries?
Your answer should be very brief. 0.98. What is the ratio of the Aid flow from UN agencies (US$) in 2010 in Fragile and conflict affected situations to that in Heavily indebted poor countries?
Make the answer very short. 0.88. What is the ratio of the Aid flow from UN agencies (US$) in 2007 in Fragile and conflict affected situations to that in Least developed countries?
Offer a very short reply. 1.01. What is the ratio of the Aid flow from UN agencies (US$) in 2008 in Fragile and conflict affected situations to that in Least developed countries?
Offer a terse response. 1.08. What is the ratio of the Aid flow from UN agencies (US$) in 2009 in Fragile and conflict affected situations to that in Least developed countries?
Your response must be concise. 1.08. What is the ratio of the Aid flow from UN agencies (US$) in 2010 in Fragile and conflict affected situations to that in Least developed countries?
Provide a succinct answer. 0.79. What is the ratio of the Aid flow from UN agencies (US$) of 2008 in Fragile and conflict affected situations to that in Low income?
Your response must be concise. 1.07. What is the ratio of the Aid flow from UN agencies (US$) of 2009 in Fragile and conflict affected situations to that in Low income?
Ensure brevity in your answer.  1.08. What is the ratio of the Aid flow from UN agencies (US$) of 2010 in Fragile and conflict affected situations to that in Low income?
Your response must be concise. 0.84. What is the ratio of the Aid flow from UN agencies (US$) of 2007 in Fragile and conflict affected situations to that in Lower middle income?
Your answer should be compact. 159.17. What is the ratio of the Aid flow from UN agencies (US$) of 2008 in Fragile and conflict affected situations to that in Lower middle income?
Your response must be concise. 10.65. What is the ratio of the Aid flow from UN agencies (US$) in 2009 in Fragile and conflict affected situations to that in Lower middle income?
Your answer should be very brief. 9.14. What is the ratio of the Aid flow from UN agencies (US$) in 2010 in Fragile and conflict affected situations to that in Lower middle income?
Offer a terse response. 7.44. What is the ratio of the Aid flow from UN agencies (US$) in 2008 in Fragile and conflict affected situations to that in Sub-Saharan Africa (all income levels)?
Provide a short and direct response. 0.97. What is the ratio of the Aid flow from UN agencies (US$) of 2009 in Fragile and conflict affected situations to that in Sub-Saharan Africa (all income levels)?
Your answer should be compact. 1.01. What is the ratio of the Aid flow from UN agencies (US$) in 2010 in Fragile and conflict affected situations to that in Sub-Saharan Africa (all income levels)?
Give a very brief answer. 0.93. What is the ratio of the Aid flow from UN agencies (US$) in 2007 in Heavily indebted poor countries to that in Least developed countries?
Make the answer very short. 1.01. What is the ratio of the Aid flow from UN agencies (US$) of 2008 in Heavily indebted poor countries to that in Least developed countries?
Ensure brevity in your answer.  1.1. What is the ratio of the Aid flow from UN agencies (US$) of 2009 in Heavily indebted poor countries to that in Least developed countries?
Offer a terse response. 1.08. What is the ratio of the Aid flow from UN agencies (US$) in 2010 in Heavily indebted poor countries to that in Least developed countries?
Keep it short and to the point. 0.9. What is the ratio of the Aid flow from UN agencies (US$) in 2007 in Heavily indebted poor countries to that in Low income?
Your answer should be very brief. 1.01. What is the ratio of the Aid flow from UN agencies (US$) of 2008 in Heavily indebted poor countries to that in Low income?
Offer a terse response. 1.09. What is the ratio of the Aid flow from UN agencies (US$) in 2009 in Heavily indebted poor countries to that in Low income?
Your answer should be very brief. 1.08. What is the ratio of the Aid flow from UN agencies (US$) of 2010 in Heavily indebted poor countries to that in Low income?
Provide a short and direct response. 0.95. What is the ratio of the Aid flow from UN agencies (US$) of 2007 in Heavily indebted poor countries to that in Lower middle income?
Your answer should be compact. 159.17. What is the ratio of the Aid flow from UN agencies (US$) in 2008 in Heavily indebted poor countries to that in Lower middle income?
Provide a succinct answer. 10.88. What is the ratio of the Aid flow from UN agencies (US$) in 2009 in Heavily indebted poor countries to that in Lower middle income?
Provide a succinct answer. 9.14. What is the ratio of the Aid flow from UN agencies (US$) in 2010 in Heavily indebted poor countries to that in Lower middle income?
Your answer should be compact. 8.46. What is the ratio of the Aid flow from UN agencies (US$) of 2007 in Heavily indebted poor countries to that in Sub-Saharan Africa (all income levels)?
Ensure brevity in your answer.  1. What is the ratio of the Aid flow from UN agencies (US$) of 2009 in Heavily indebted poor countries to that in Sub-Saharan Africa (all income levels)?
Keep it short and to the point. 1.01. What is the ratio of the Aid flow from UN agencies (US$) of 2010 in Heavily indebted poor countries to that in Sub-Saharan Africa (all income levels)?
Provide a succinct answer. 1.05. What is the ratio of the Aid flow from UN agencies (US$) in 2008 in Least developed countries to that in Low income?
Give a very brief answer. 0.99. What is the ratio of the Aid flow from UN agencies (US$) in 2010 in Least developed countries to that in Low income?
Provide a succinct answer. 1.05. What is the ratio of the Aid flow from UN agencies (US$) in 2007 in Least developed countries to that in Lower middle income?
Your response must be concise. 158.17. What is the ratio of the Aid flow from UN agencies (US$) in 2008 in Least developed countries to that in Lower middle income?
Offer a very short reply. 9.88. What is the ratio of the Aid flow from UN agencies (US$) of 2009 in Least developed countries to that in Lower middle income?
Offer a terse response. 8.44. What is the ratio of the Aid flow from UN agencies (US$) in 2010 in Least developed countries to that in Lower middle income?
Your answer should be very brief. 9.36. What is the ratio of the Aid flow from UN agencies (US$) of 2007 in Least developed countries to that in Sub-Saharan Africa (all income levels)?
Keep it short and to the point. 0.99. What is the ratio of the Aid flow from UN agencies (US$) of 2008 in Least developed countries to that in Sub-Saharan Africa (all income levels)?
Your response must be concise. 0.9. What is the ratio of the Aid flow from UN agencies (US$) of 2009 in Least developed countries to that in Sub-Saharan Africa (all income levels)?
Give a very brief answer. 0.93. What is the ratio of the Aid flow from UN agencies (US$) in 2010 in Least developed countries to that in Sub-Saharan Africa (all income levels)?
Offer a very short reply. 1.17. What is the ratio of the Aid flow from UN agencies (US$) of 2007 in Low income to that in Lower middle income?
Ensure brevity in your answer.  158.17. What is the ratio of the Aid flow from UN agencies (US$) of 2008 in Low income to that in Lower middle income?
Ensure brevity in your answer.  9.98. What is the ratio of the Aid flow from UN agencies (US$) of 2009 in Low income to that in Lower middle income?
Provide a succinct answer. 8.48. What is the ratio of the Aid flow from UN agencies (US$) of 2010 in Low income to that in Lower middle income?
Make the answer very short. 8.91. What is the ratio of the Aid flow from UN agencies (US$) in 2007 in Low income to that in Sub-Saharan Africa (all income levels)?
Provide a succinct answer. 0.99. What is the ratio of the Aid flow from UN agencies (US$) of 2008 in Low income to that in Sub-Saharan Africa (all income levels)?
Keep it short and to the point. 0.91. What is the ratio of the Aid flow from UN agencies (US$) of 2009 in Low income to that in Sub-Saharan Africa (all income levels)?
Offer a terse response. 0.94. What is the ratio of the Aid flow from UN agencies (US$) of 2010 in Low income to that in Sub-Saharan Africa (all income levels)?
Your answer should be very brief. 1.11. What is the ratio of the Aid flow from UN agencies (US$) of 2007 in Lower middle income to that in Sub-Saharan Africa (all income levels)?
Provide a short and direct response. 0.01. What is the ratio of the Aid flow from UN agencies (US$) in 2008 in Lower middle income to that in Sub-Saharan Africa (all income levels)?
Make the answer very short. 0.09. What is the ratio of the Aid flow from UN agencies (US$) in 2009 in Lower middle income to that in Sub-Saharan Africa (all income levels)?
Give a very brief answer. 0.11. What is the ratio of the Aid flow from UN agencies (US$) in 2010 in Lower middle income to that in Sub-Saharan Africa (all income levels)?
Your response must be concise. 0.12. What is the difference between the highest and the second highest Aid flow from UN agencies (US$) of 2007?
Ensure brevity in your answer.  0. What is the difference between the highest and the second highest Aid flow from UN agencies (US$) in 2008?
Offer a terse response. 4.00e+05. What is the difference between the highest and the second highest Aid flow from UN agencies (US$) in 2010?
Keep it short and to the point. 2.32e+06. What is the difference between the highest and the lowest Aid flow from UN agencies (US$) in 2007?
Your answer should be compact. 9.49e+06. What is the difference between the highest and the lowest Aid flow from UN agencies (US$) of 2008?
Your response must be concise. 3.05e+07. What is the difference between the highest and the lowest Aid flow from UN agencies (US$) in 2009?
Offer a terse response. 3.66e+07. What is the difference between the highest and the lowest Aid flow from UN agencies (US$) of 2010?
Your response must be concise. 4.30e+07. 